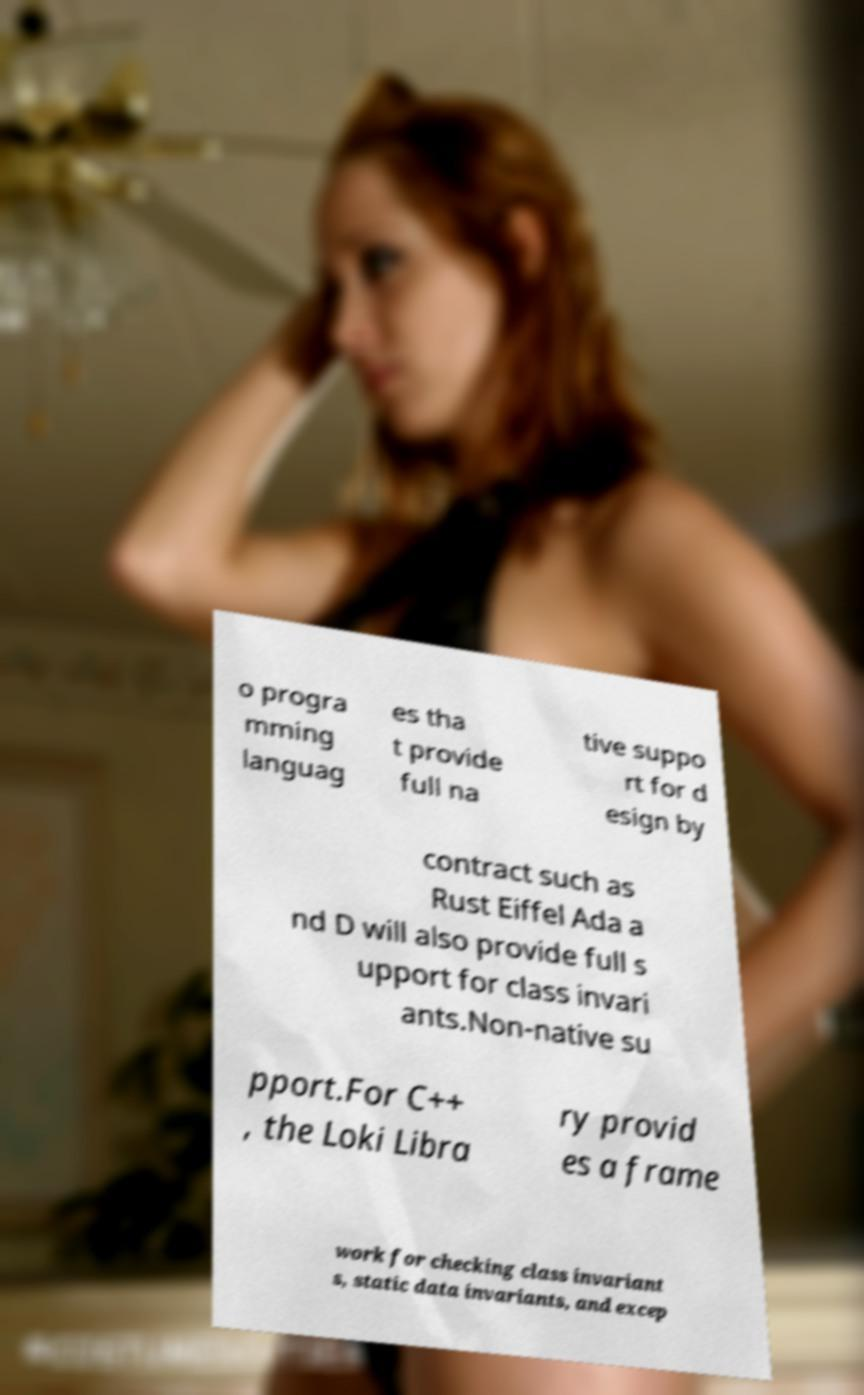What messages or text are displayed in this image? I need them in a readable, typed format. o progra mming languag es tha t provide full na tive suppo rt for d esign by contract such as Rust Eiffel Ada a nd D will also provide full s upport for class invari ants.Non-native su pport.For C++ , the Loki Libra ry provid es a frame work for checking class invariant s, static data invariants, and excep 